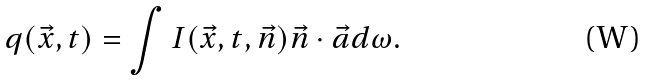Convert formula to latex. <formula><loc_0><loc_0><loc_500><loc_500>q ( \vec { x } , t ) = \int I ( \vec { x } , t , \vec { n } ) \vec { n } \cdot \vec { a } d \omega .</formula> 